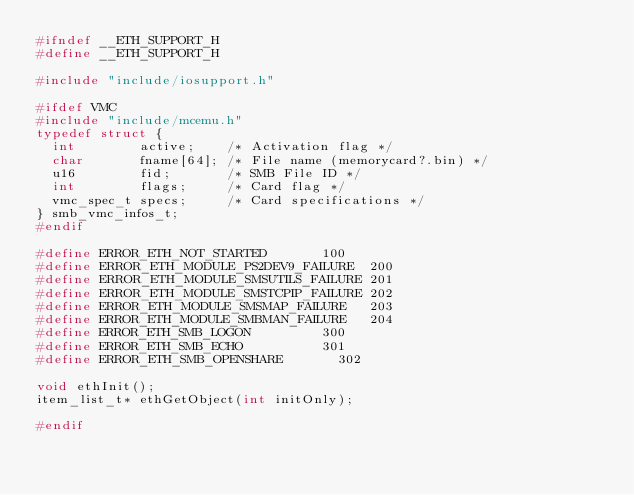<code> <loc_0><loc_0><loc_500><loc_500><_C_>#ifndef __ETH_SUPPORT_H
#define __ETH_SUPPORT_H

#include "include/iosupport.h"

#ifdef VMC
#include "include/mcemu.h"
typedef struct {
	int        active;    /* Activation flag */
	char       fname[64]; /* File name (memorycard?.bin) */
	u16        fid;       /* SMB File ID */
	int        flags;     /* Card flag */
	vmc_spec_t specs;     /* Card specifications */
} smb_vmc_infos_t;
#endif

#define ERROR_ETH_NOT_STARTED				100
#define ERROR_ETH_MODULE_PS2DEV9_FAILURE	200
#define ERROR_ETH_MODULE_SMSUTILS_FAILURE	201
#define ERROR_ETH_MODULE_SMSTCPIP_FAILURE	202
#define ERROR_ETH_MODULE_SMSMAP_FAILURE		203
#define ERROR_ETH_MODULE_SMBMAN_FAILURE		204
#define ERROR_ETH_SMB_LOGON					300
#define ERROR_ETH_SMB_ECHO					301
#define ERROR_ETH_SMB_OPENSHARE				302

void ethInit();
item_list_t* ethGetObject(int initOnly);

#endif
</code> 